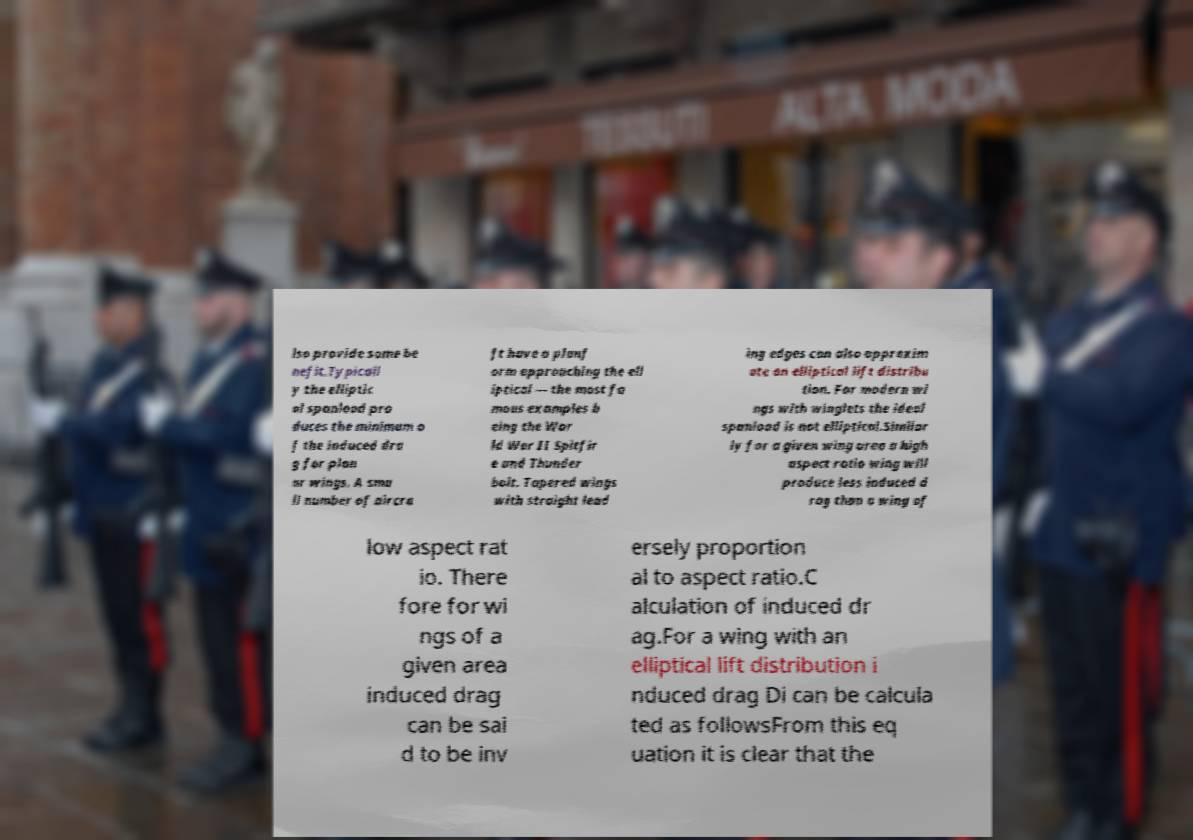I need the written content from this picture converted into text. Can you do that? lso provide some be nefit.Typicall y the elliptic al spanload pro duces the minimum o f the induced dra g for plan ar wings. A sma ll number of aircra ft have a planf orm approaching the ell iptical — the most fa mous examples b eing the Wor ld War II Spitfir e and Thunder bolt. Tapered wings with straight lead ing edges can also approxim ate an elliptical lift distribu tion. For modern wi ngs with winglets the ideal spanload is not elliptical.Similar ly for a given wing area a high aspect ratio wing will produce less induced d rag than a wing of low aspect rat io. There fore for wi ngs of a given area induced drag can be sai d to be inv ersely proportion al to aspect ratio.C alculation of induced dr ag.For a wing with an elliptical lift distribution i nduced drag Di can be calcula ted as followsFrom this eq uation it is clear that the 